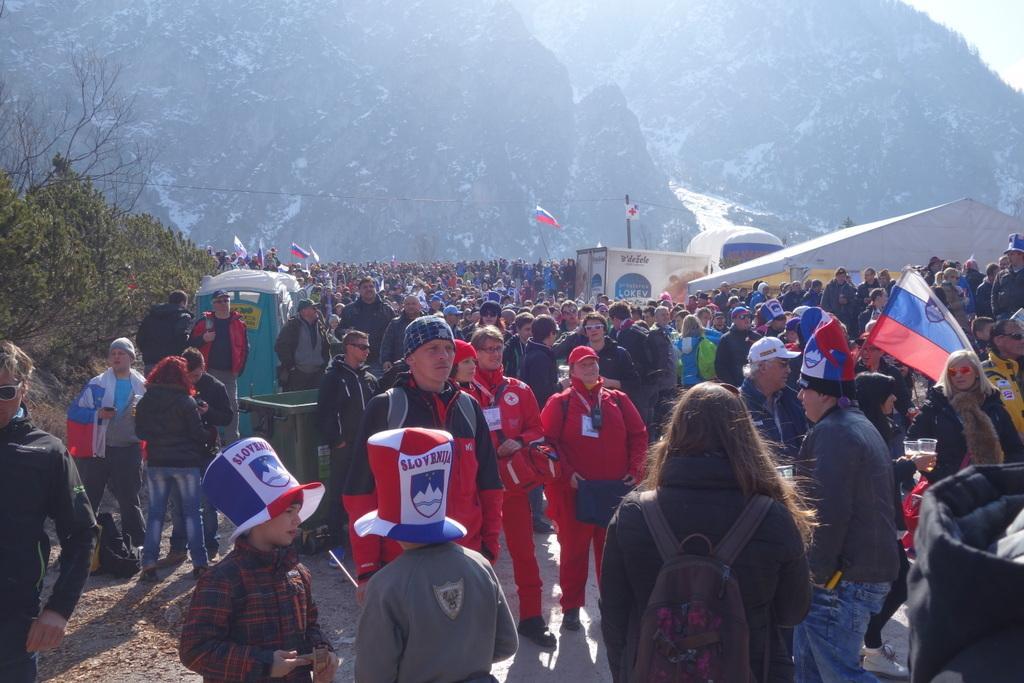Please provide a concise description of this image. In this picture there are many people in the center of the image and there are plants on the left side of the image, there are mountains in the background area of the image. 